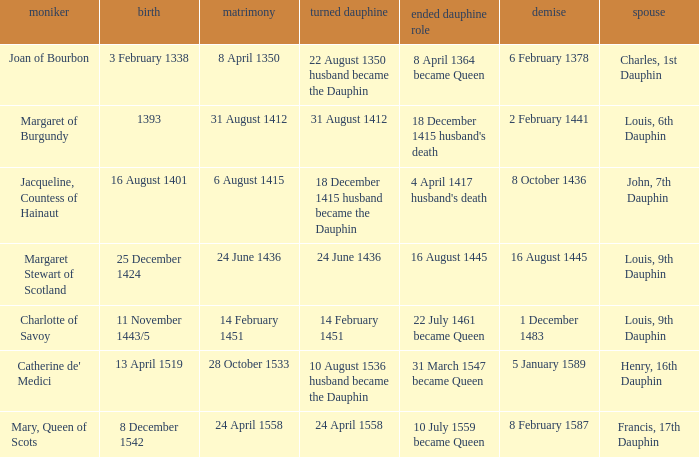When was the marriage when became dauphine is 31 august 1412? 31 August 1412. 